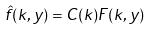<formula> <loc_0><loc_0><loc_500><loc_500>\hat { f } ( k , y ) = C ( k ) F ( k , y )</formula> 